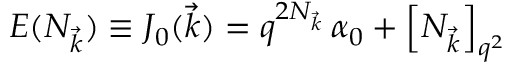<formula> <loc_0><loc_0><loc_500><loc_500>E ( N _ { \vec { k } } ) \equiv J _ { 0 } ( \vec { k } ) = q ^ { 2 N _ { \vec { k } } } \, \alpha _ { 0 } + \left [ N _ { \vec { k } } \right ] _ { q ^ { 2 } }</formula> 